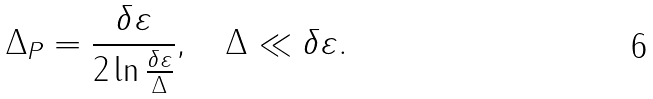Convert formula to latex. <formula><loc_0><loc_0><loc_500><loc_500>\Delta _ { P } = \frac { \delta \varepsilon } { 2 \ln \frac { \delta \varepsilon } { \Delta } } , \quad \Delta \ll \delta \varepsilon .</formula> 